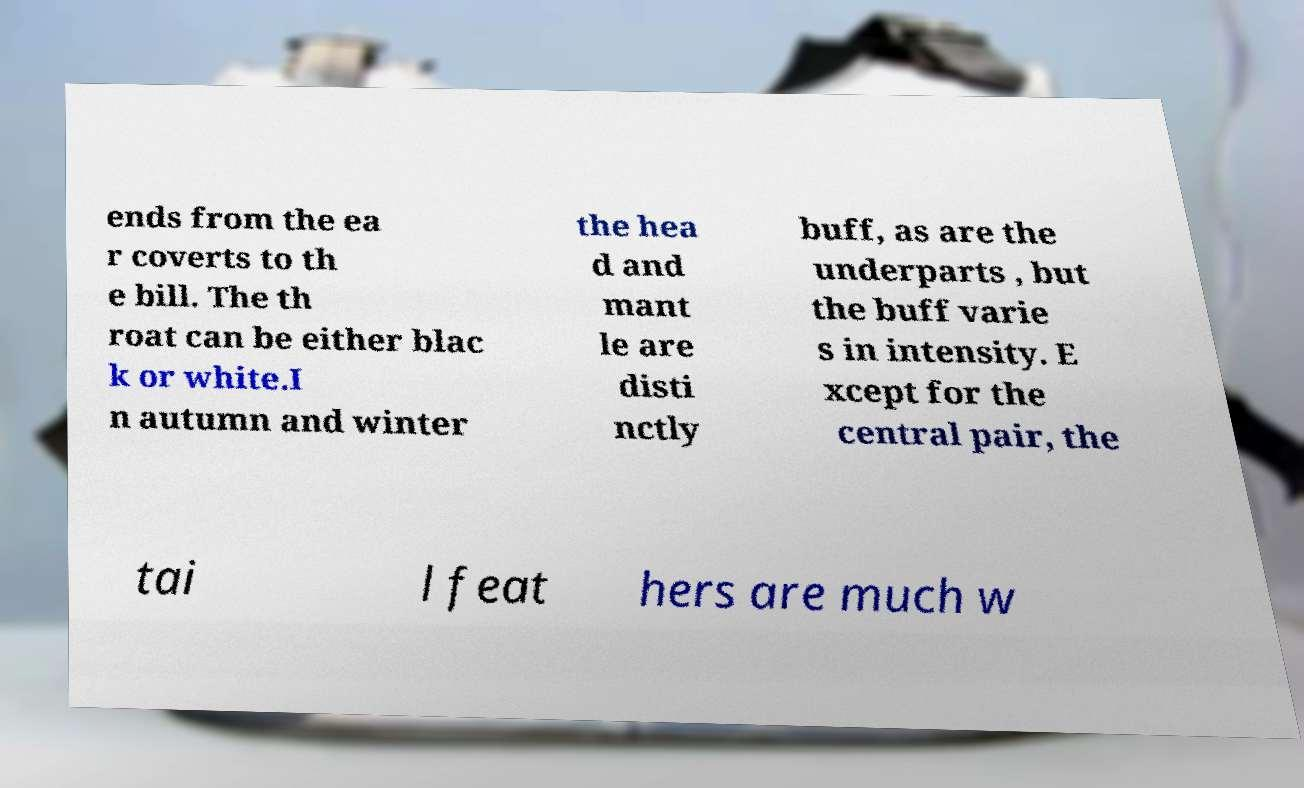Can you read and provide the text displayed in the image?This photo seems to have some interesting text. Can you extract and type it out for me? ends from the ea r coverts to th e bill. The th roat can be either blac k or white.I n autumn and winter the hea d and mant le are disti nctly buff, as are the underparts , but the buff varie s in intensity. E xcept for the central pair, the tai l feat hers are much w 